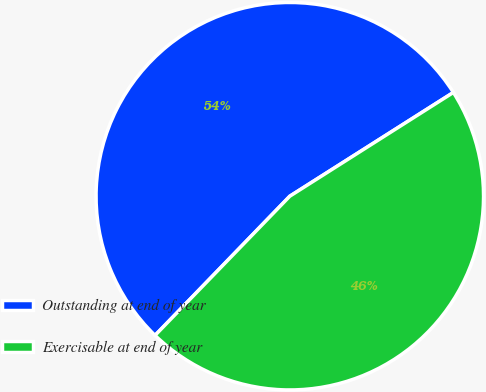Convert chart to OTSL. <chart><loc_0><loc_0><loc_500><loc_500><pie_chart><fcel>Outstanding at end of year<fcel>Exercisable at end of year<nl><fcel>53.76%<fcel>46.24%<nl></chart> 